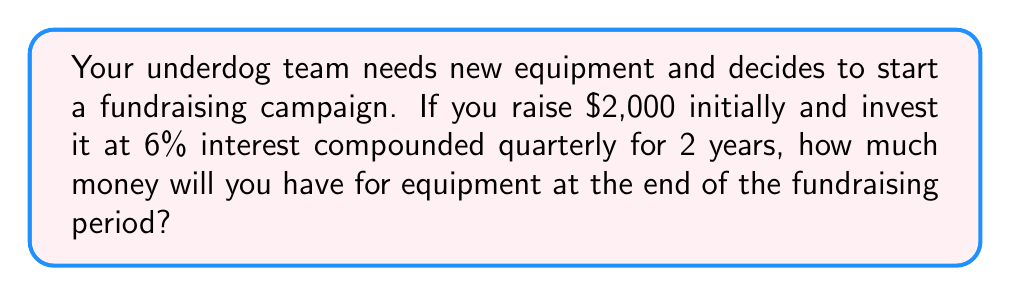What is the answer to this math problem? Let's approach this step-by-step using the compound interest formula:

$$A = P(1 + \frac{r}{n})^{nt}$$

Where:
$A$ = final amount
$P$ = principal (initial investment)
$r$ = annual interest rate (in decimal form)
$n$ = number of times interest is compounded per year
$t$ = number of years

Given:
$P = 2000$
$r = 0.06$ (6% converted to decimal)
$n = 4$ (compounded quarterly means 4 times per year)
$t = 2$ years

Let's substitute these values into the formula:

$$A = 2000(1 + \frac{0.06}{4})^{4(2)}$$

$$A = 2000(1 + 0.015)^8$$

$$A = 2000(1.015)^8$$

Now, let's calculate:

$$A = 2000 \times 1.12616$$

$$A = 2252.32$$
Answer: $2252.32 